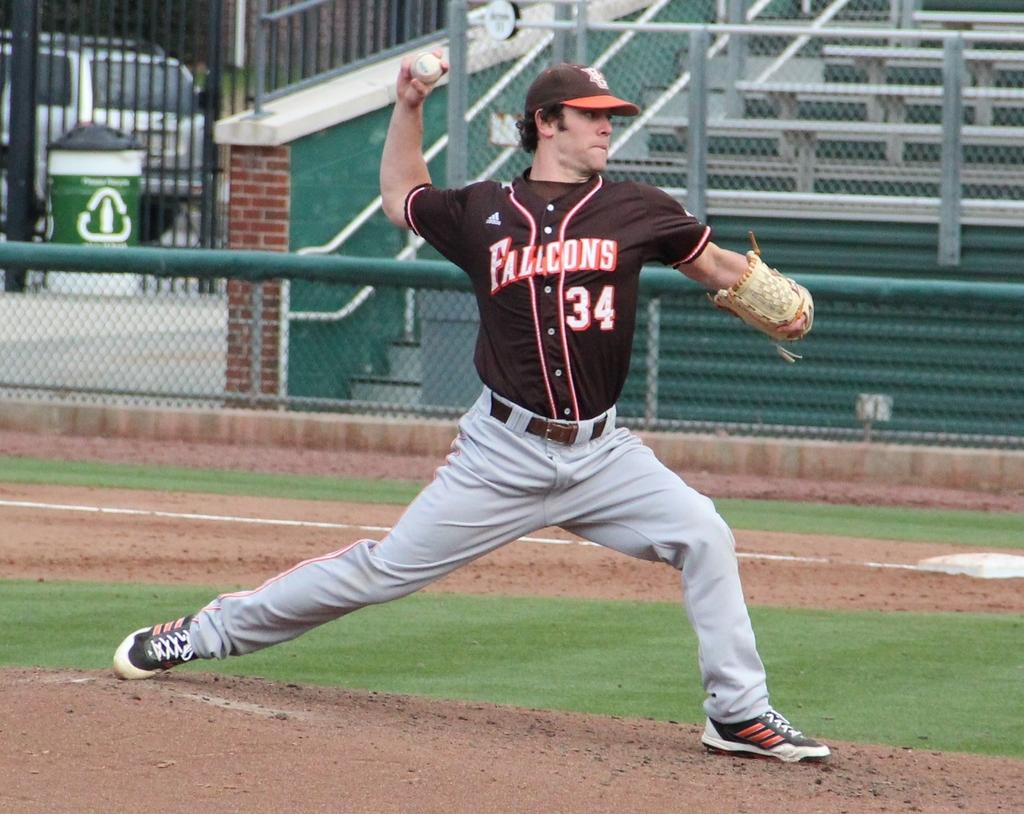<image>
Summarize the visual content of the image. the number 34 is on a black jersey 